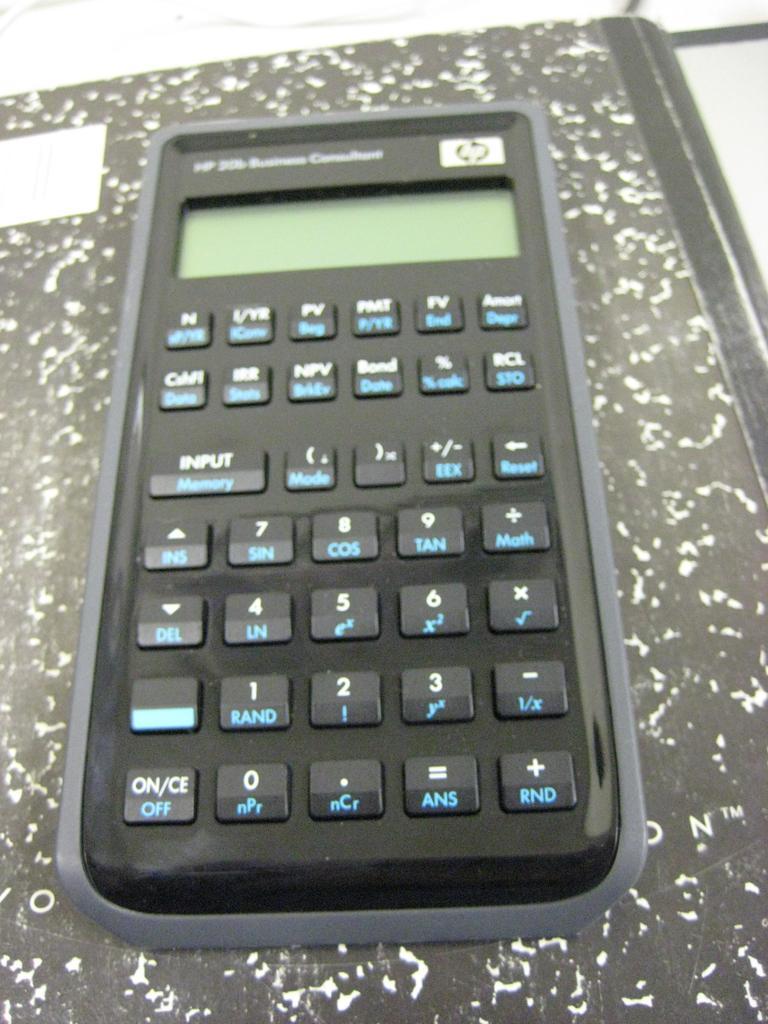Who is the maker of this calculator?
Your answer should be compact. Hp. What word is in blue on the bottom left button?
Provide a short and direct response. Off. 